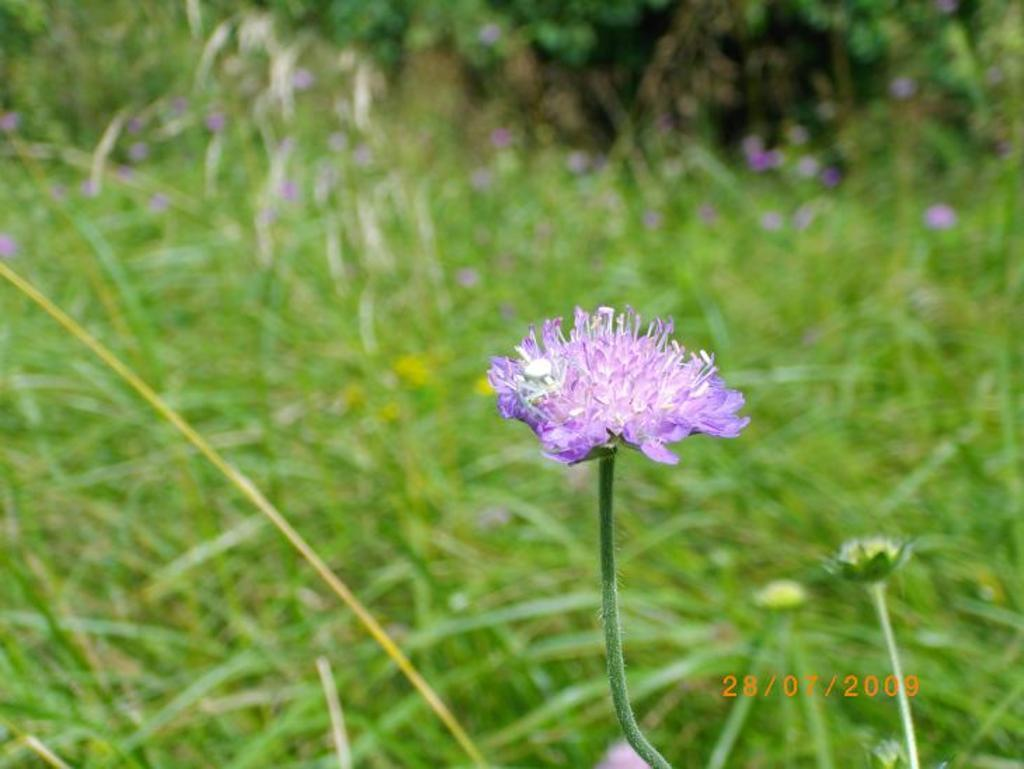What type of plant life is present in the image? There are flowers and grass in the image. Can you describe any specific features of the flowers? The flowers have stems in the image. Is there any text visible in the image? Yes, the date is visible in the bottom right side of the image. What type of straw is being used to decorate the garden in the image? There is no straw present in the image, and the image does not depict a garden. 